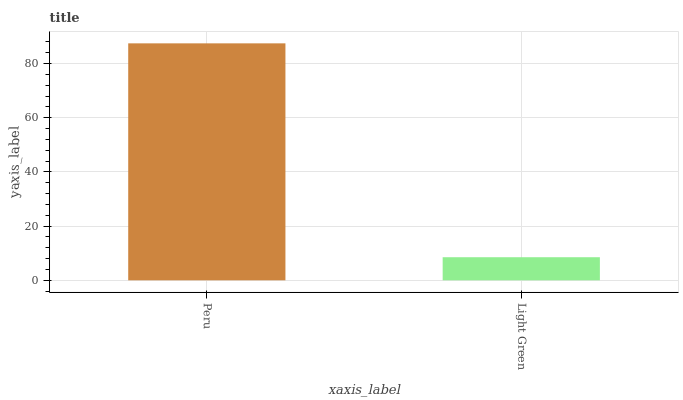Is Light Green the minimum?
Answer yes or no. Yes. Is Peru the maximum?
Answer yes or no. Yes. Is Light Green the maximum?
Answer yes or no. No. Is Peru greater than Light Green?
Answer yes or no. Yes. Is Light Green less than Peru?
Answer yes or no. Yes. Is Light Green greater than Peru?
Answer yes or no. No. Is Peru less than Light Green?
Answer yes or no. No. Is Peru the high median?
Answer yes or no. Yes. Is Light Green the low median?
Answer yes or no. Yes. Is Light Green the high median?
Answer yes or no. No. Is Peru the low median?
Answer yes or no. No. 